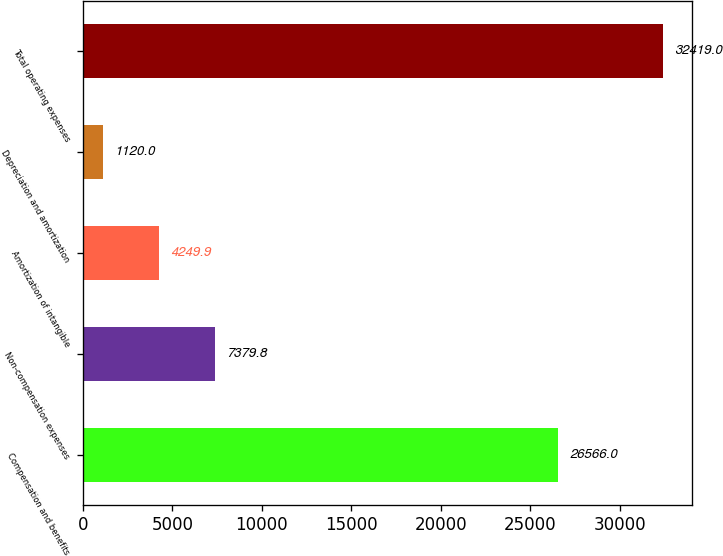Convert chart. <chart><loc_0><loc_0><loc_500><loc_500><bar_chart><fcel>Compensation and benefits<fcel>Non-compensation expenses<fcel>Amortization of intangible<fcel>Depreciation and amortization<fcel>Total operating expenses<nl><fcel>26566<fcel>7379.8<fcel>4249.9<fcel>1120<fcel>32419<nl></chart> 